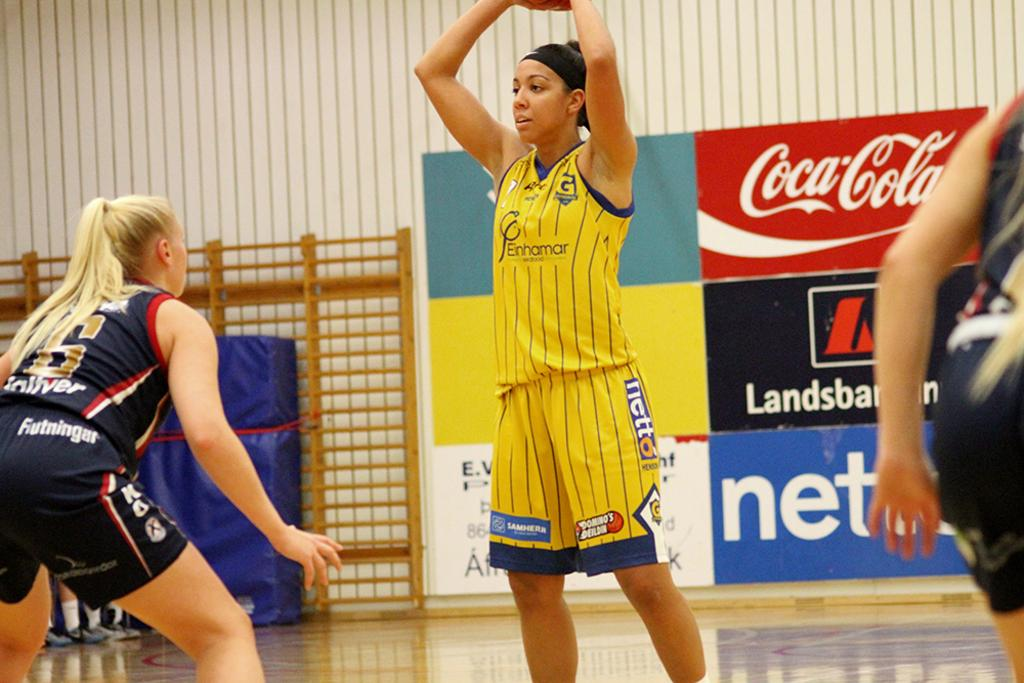<image>
Share a concise interpretation of the image provided. A player with a jersey sponsored by Einhamar Seafood holds a basketball over her head while looking for teammates. 